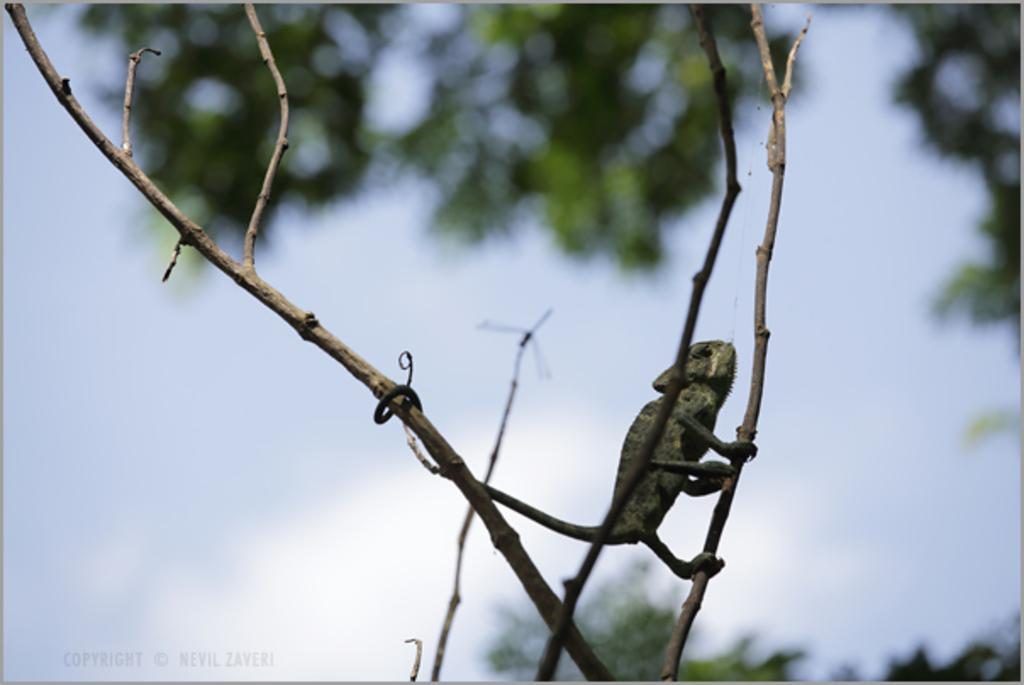What type of animal is in the image? There is a chameleon in the image. Where is the chameleon located? The chameleon is on a tree stem. What type of play is the mother engaging in with the chameleon in the image? There is no mother or play present in the image; it features a chameleon on a tree stem. 